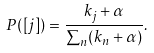Convert formula to latex. <formula><loc_0><loc_0><loc_500><loc_500>P ( [ j ] ) = \frac { k _ { j } + \alpha } { \sum _ { n } ( k _ { n } + \alpha ) } .</formula> 